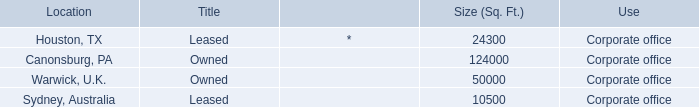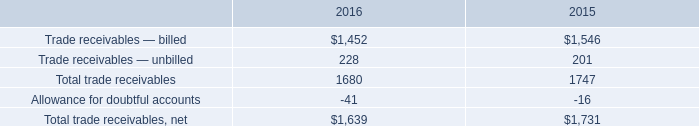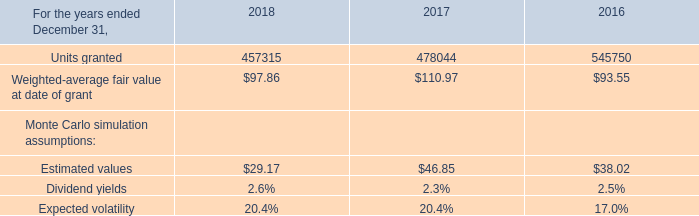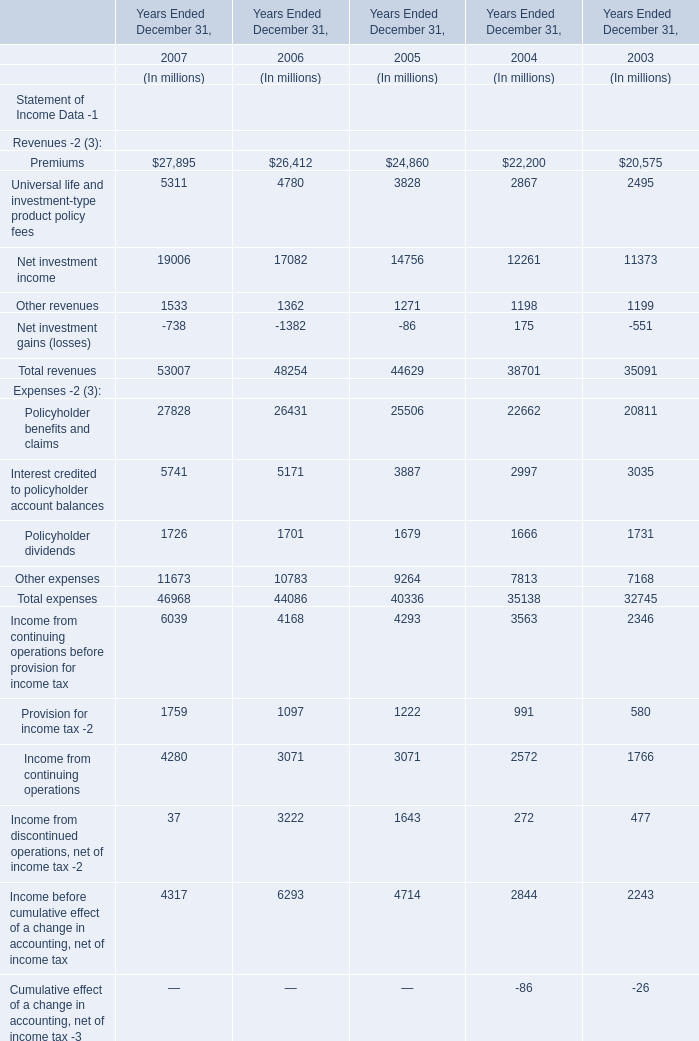What was the value of the net income in the Year(Ended December 31) where Net income available to common shareholders is the highest? (in million) 
Answer: 6293. 